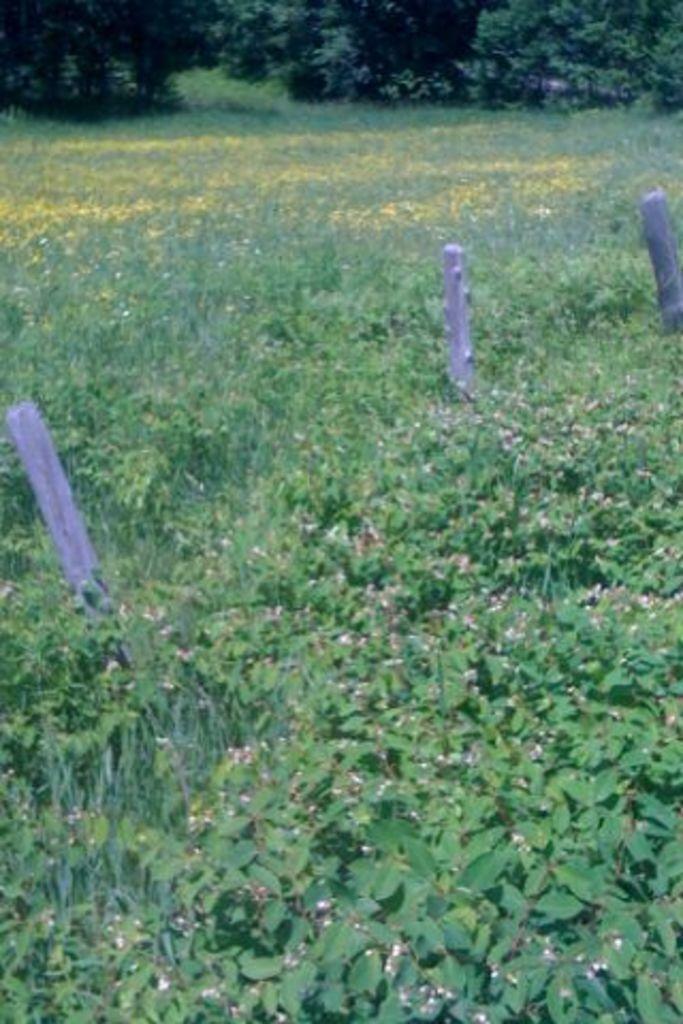Can you describe this image briefly? In this image we can see group of plants ,poles on the ground. In the background we can see several trees. 